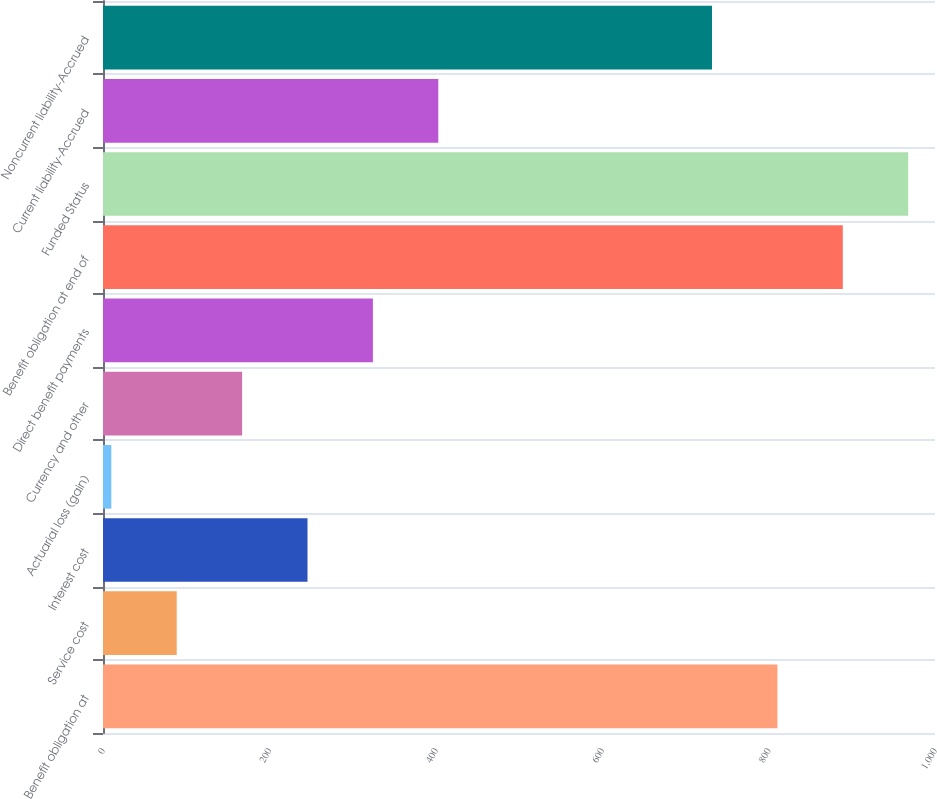Convert chart to OTSL. <chart><loc_0><loc_0><loc_500><loc_500><bar_chart><fcel>Benefit obligation at<fcel>Service cost<fcel>Interest cost<fcel>Actuarial loss (gain)<fcel>Currency and other<fcel>Direct benefit payments<fcel>Benefit obligation at end of<fcel>Funded Status<fcel>Current liability-Accrued<fcel>Noncurrent liability-Accrued<nl><fcel>810.6<fcel>88.6<fcel>245.8<fcel>10<fcel>167.2<fcel>324.4<fcel>889.2<fcel>967.8<fcel>403<fcel>732<nl></chart> 